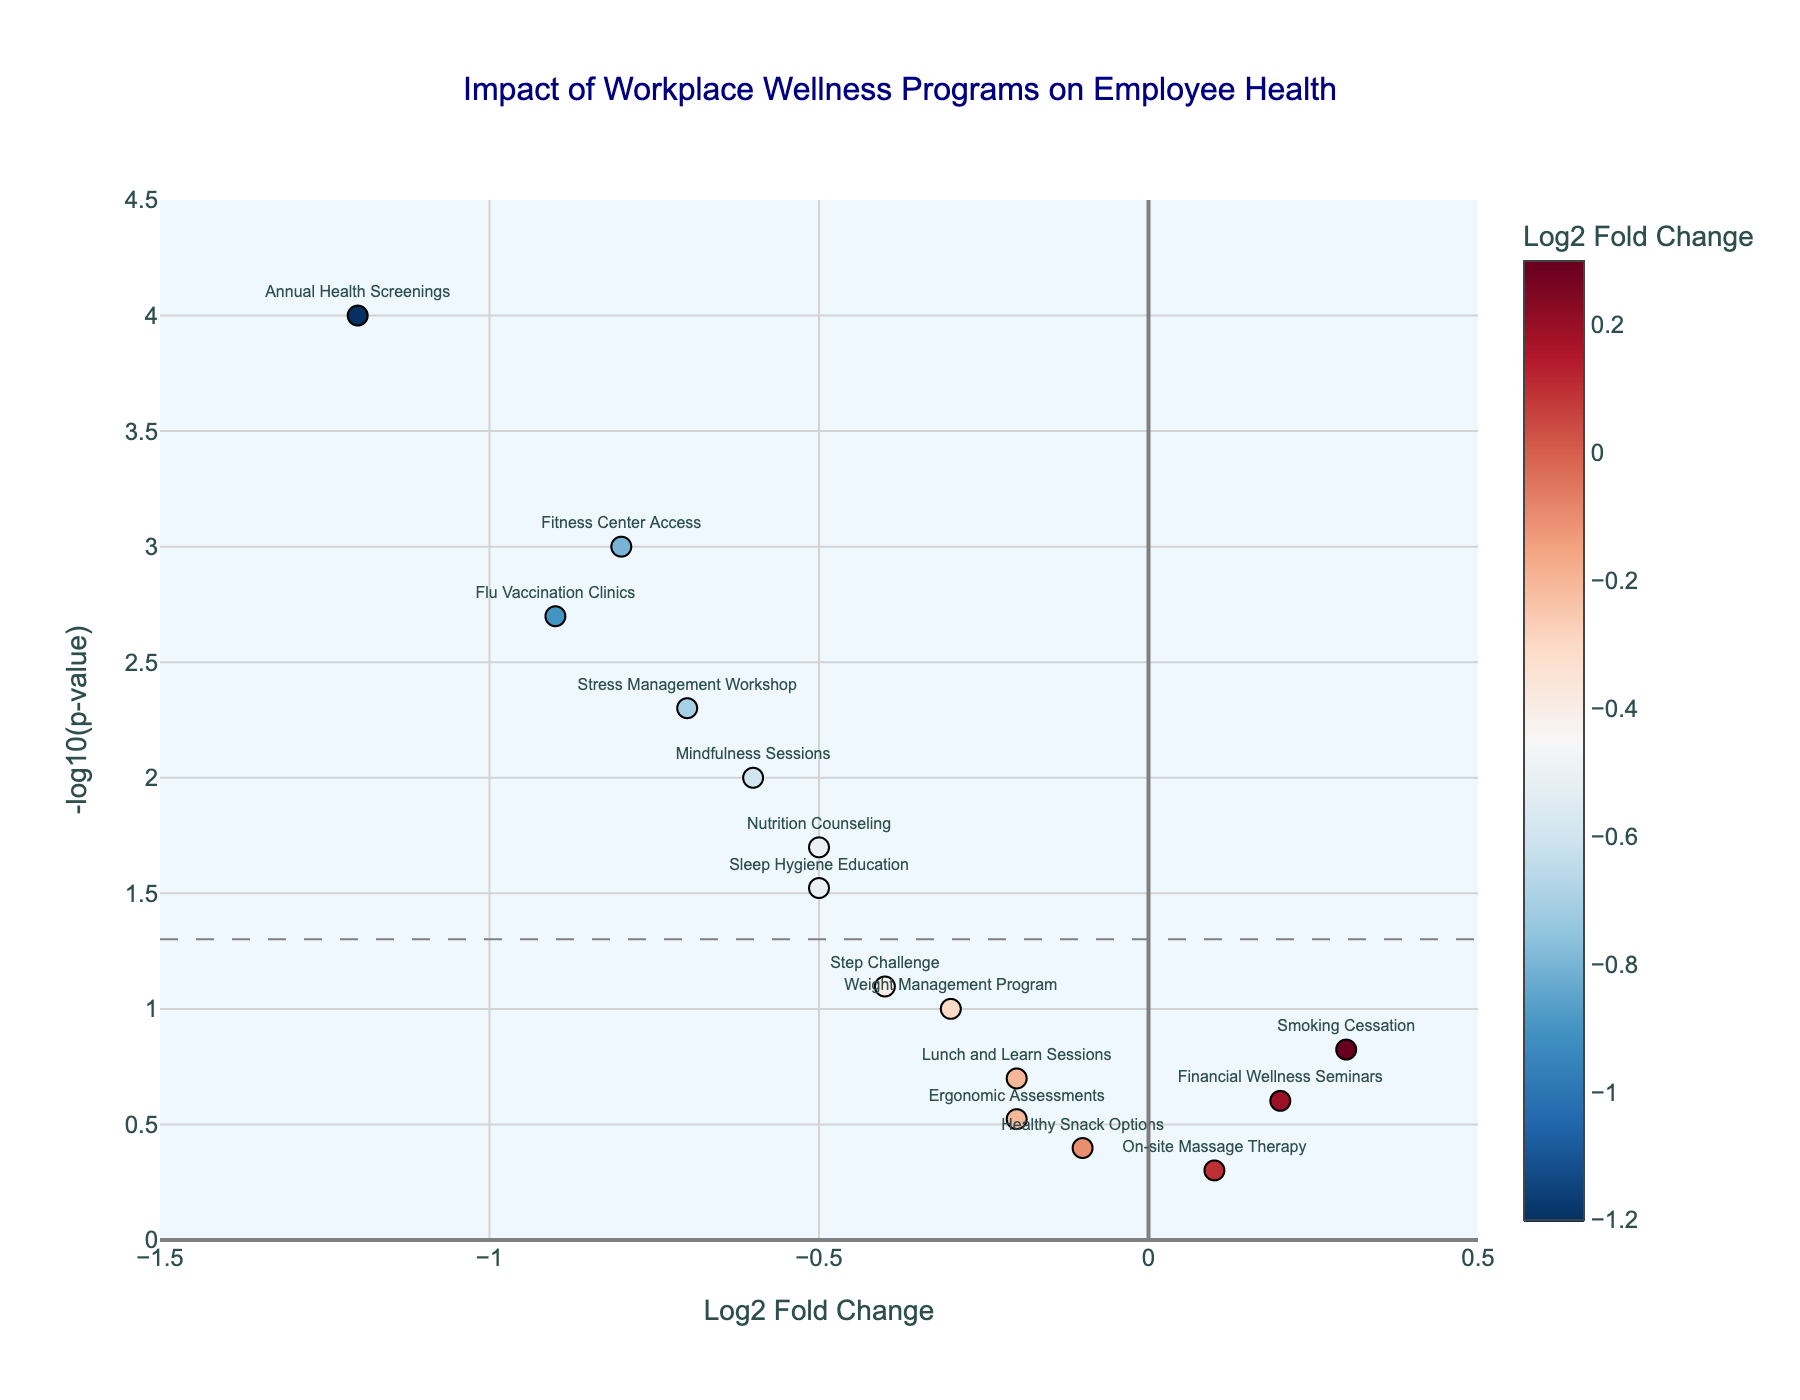How many workplace wellness programs are plotted in the figure? Count the number of data points, which represent the different programs.
Answer: 15 What does the title of the plot indicate? Read the text at the top of the plot for the title.
Answer: Impact of Workplace Wellness Programs on Employee Health Which program has the lowest log2 fold change? Look at the highest negative value on the x-axis and identify the corresponding point and text label.
Answer: Annual Health Screenings Which program has the highest -log10(p-value) (i.e., the smallest p-value)? Find the highest point on the y-axis and read the associated label.
Answer: Annual Health Screenings How many programs have a log2 fold change less than 0? Count the number of points to the left of the vertical line at x=0.
Answer: 11 Which two programs have log2 fold changes closest to zero? Look for the two points closest to the vertical axis (x=0) and read their labels.
Answer: On-site Massage Therapy and Healthy Snack Options Which program has the largest positive log2 fold change? Look for the highest point to the right of the vertical line at x=0 and read the associated text label.
Answer: Smoking Cessation What percentage of the programs have a p-value less than 0.05? Count the number of points above -log10(p-value)=1.3 (since -log10(0.05) ≈ 1.3) and divide by the total number of points, then multiply by 100.
Answer: (10/15) * 100 = 66.67% What does a point's position above -log10(p-value)=1.3 represent in terms of significance? Refer to the horizontal dashed line indicating the significance threshold. Programs above this line have p-values less than 0.05, indicating statistical significance.
Answer: Statistically significant Among the programs that are statistically significant, which program shows the smallest improvement (least negative log2 fold change)? Identify the significant points (above the threshold line) and find the one with the smallest negative value on the x-axis (closest to zero).
Answer: Step Challenge 